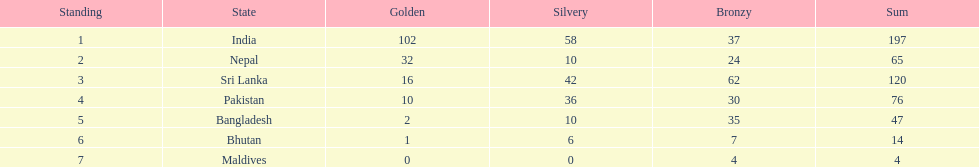How many countries have one more than 10 gold medals? 3. 